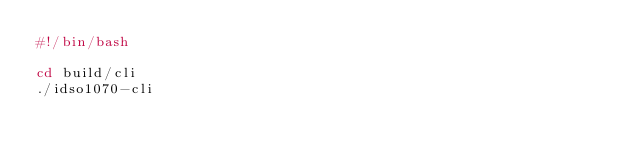<code> <loc_0><loc_0><loc_500><loc_500><_Bash_>#!/bin/bash

cd build/cli
./idso1070-cli</code> 